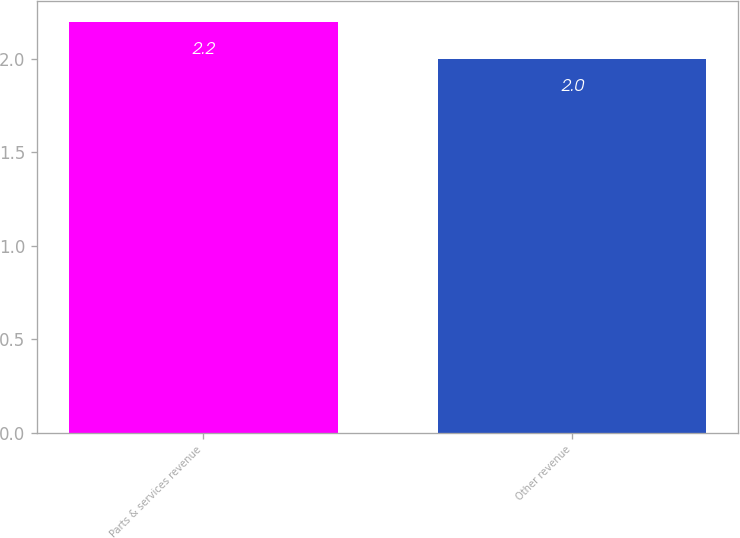<chart> <loc_0><loc_0><loc_500><loc_500><bar_chart><fcel>Parts & services revenue<fcel>Other revenue<nl><fcel>2.2<fcel>2<nl></chart> 